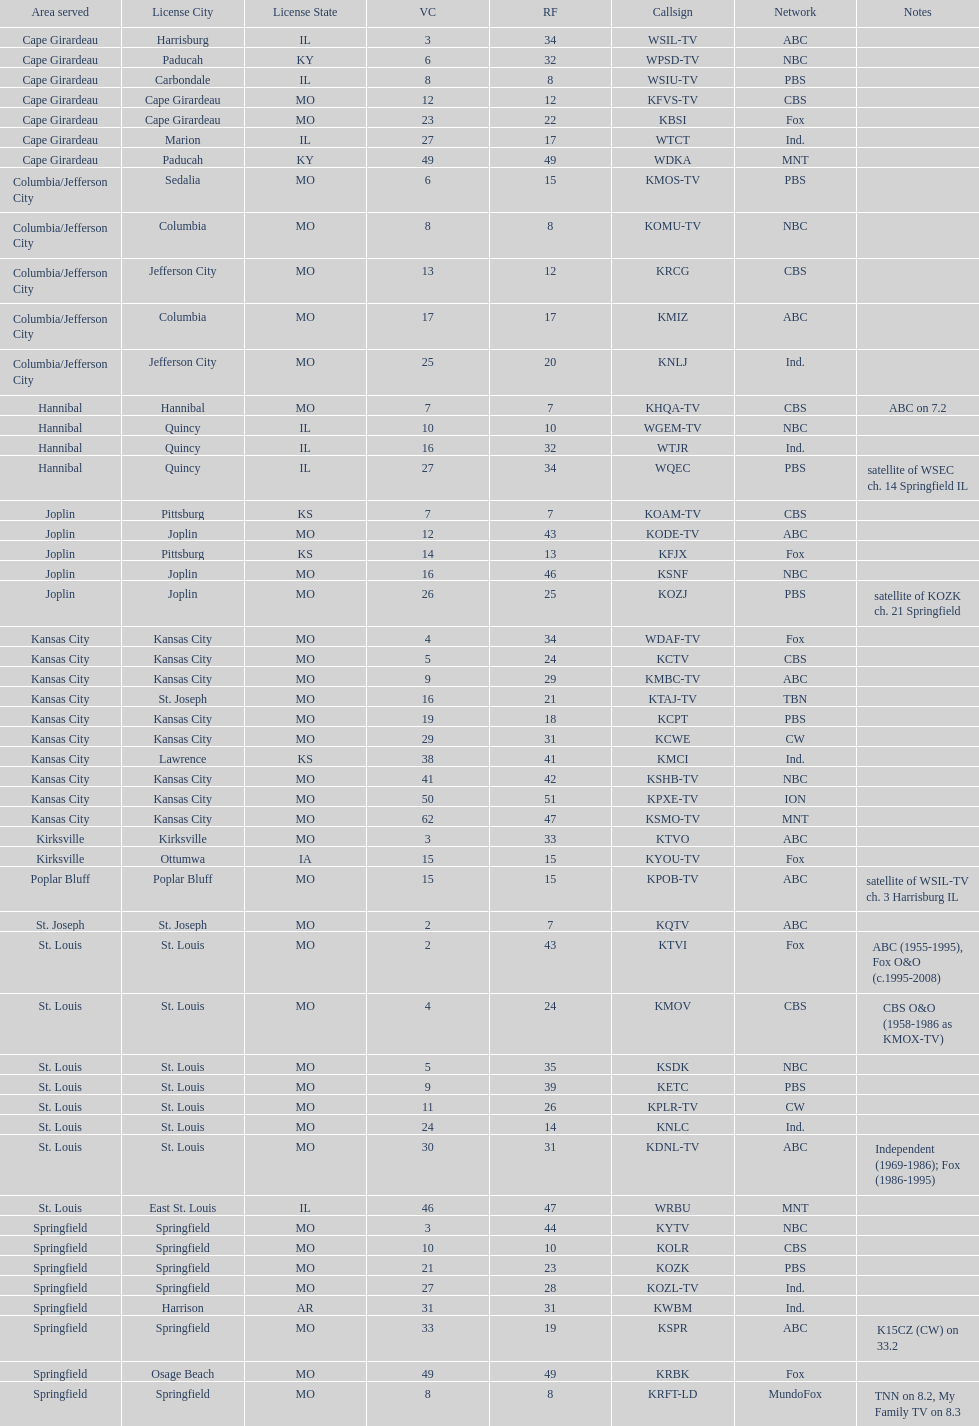How many are on the cbs network? 7. 